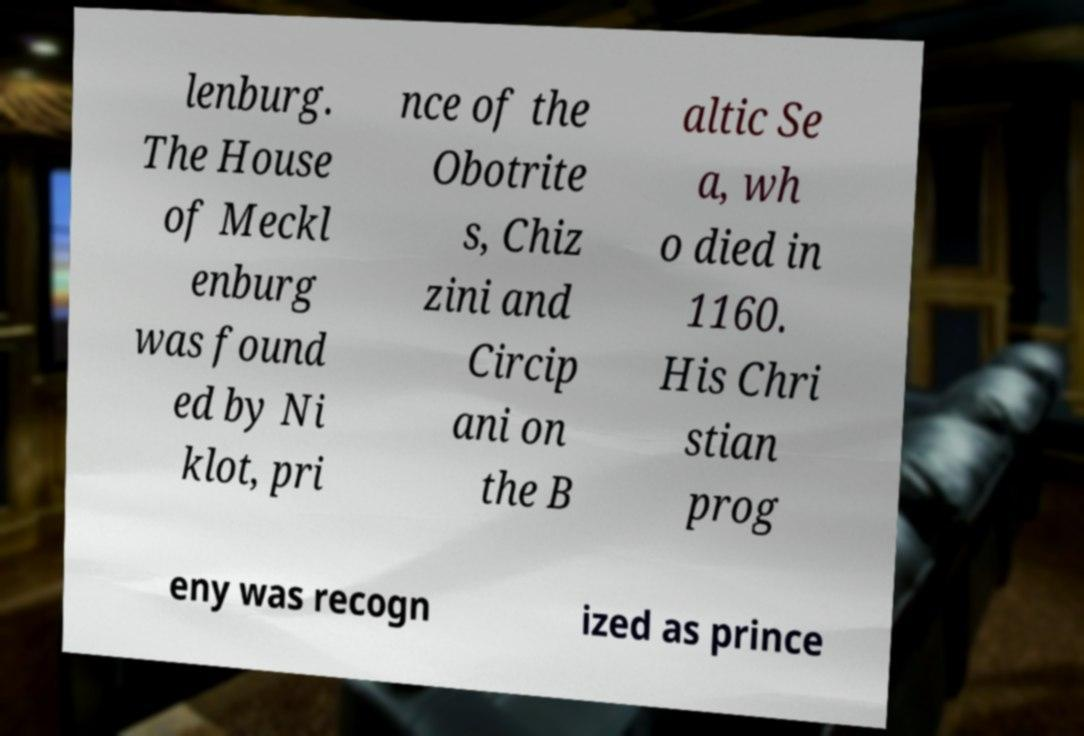Could you extract and type out the text from this image? lenburg. The House of Meckl enburg was found ed by Ni klot, pri nce of the Obotrite s, Chiz zini and Circip ani on the B altic Se a, wh o died in 1160. His Chri stian prog eny was recogn ized as prince 